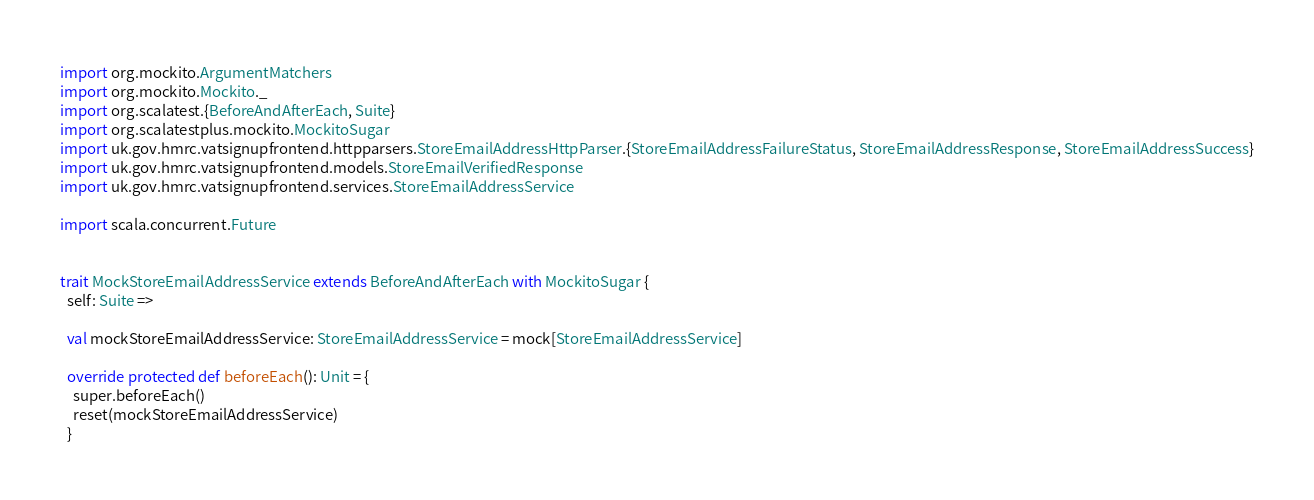Convert code to text. <code><loc_0><loc_0><loc_500><loc_500><_Scala_>
import org.mockito.ArgumentMatchers
import org.mockito.Mockito._
import org.scalatest.{BeforeAndAfterEach, Suite}
import org.scalatestplus.mockito.MockitoSugar
import uk.gov.hmrc.vatsignupfrontend.httpparsers.StoreEmailAddressHttpParser.{StoreEmailAddressFailureStatus, StoreEmailAddressResponse, StoreEmailAddressSuccess}
import uk.gov.hmrc.vatsignupfrontend.models.StoreEmailVerifiedResponse
import uk.gov.hmrc.vatsignupfrontend.services.StoreEmailAddressService

import scala.concurrent.Future


trait MockStoreEmailAddressService extends BeforeAndAfterEach with MockitoSugar {
  self: Suite =>

  val mockStoreEmailAddressService: StoreEmailAddressService = mock[StoreEmailAddressService]

  override protected def beforeEach(): Unit = {
    super.beforeEach()
    reset(mockStoreEmailAddressService)
  }
</code> 